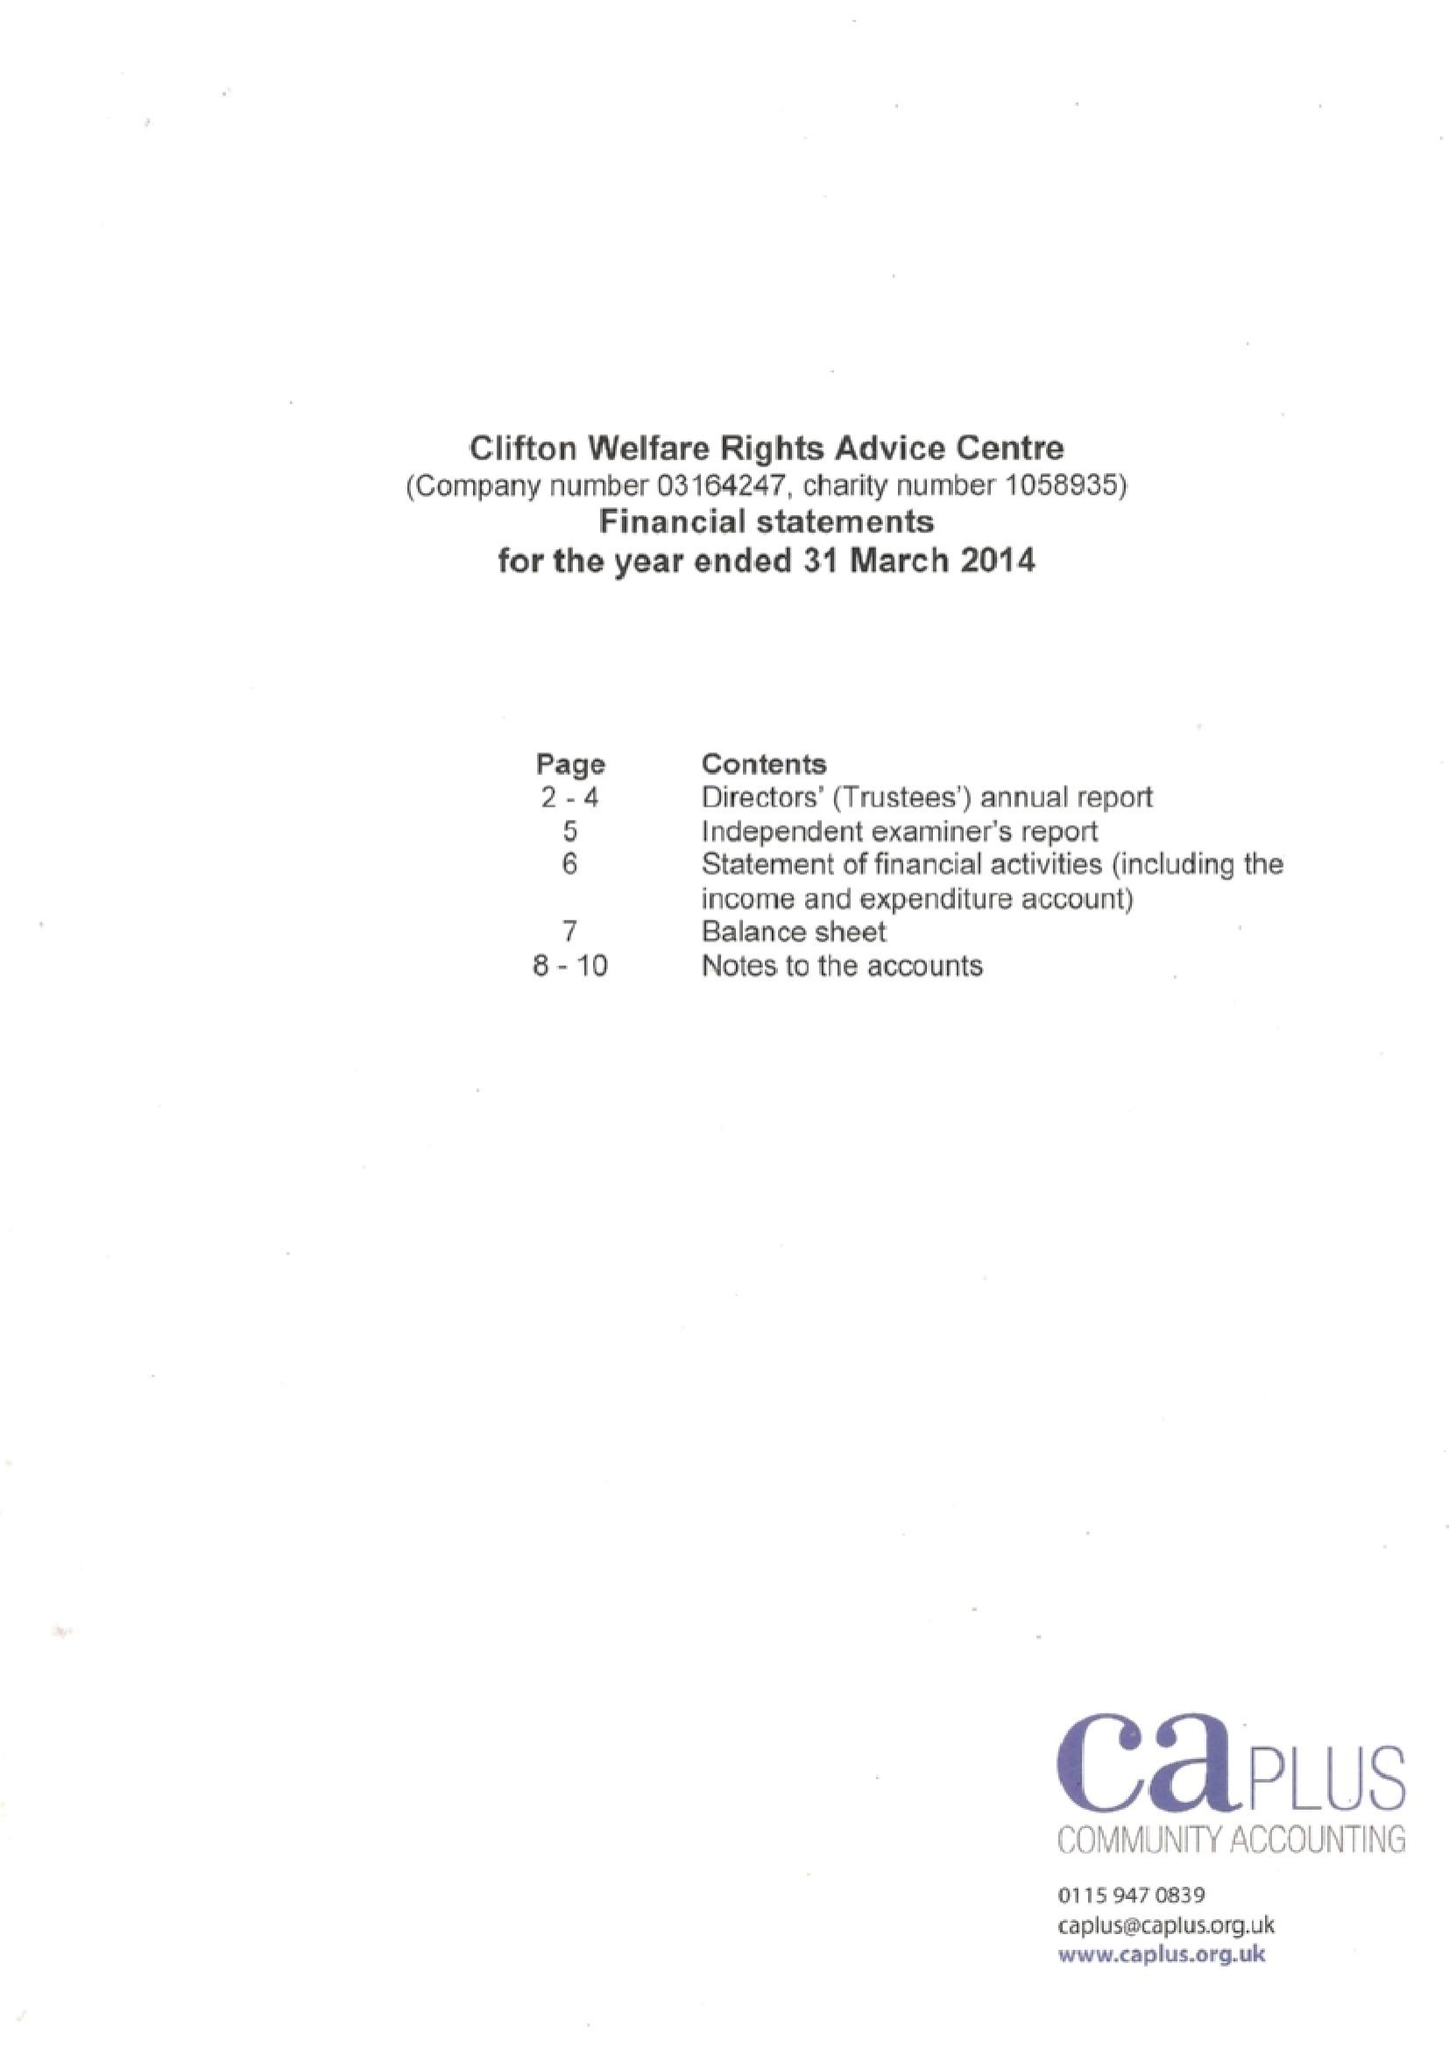What is the value for the spending_annually_in_british_pounds?
Answer the question using a single word or phrase. 81753.00 